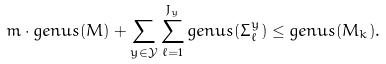Convert formula to latex. <formula><loc_0><loc_0><loc_500><loc_500>m \cdot g e n u s ( M ) + \sum _ { y \in \mathcal { Y } } \sum _ { \ell = 1 } ^ { J _ { y } } g e n u s ( \Sigma ^ { y } _ { \ell } ) \leq g e n u s ( M _ { k } ) .</formula> 